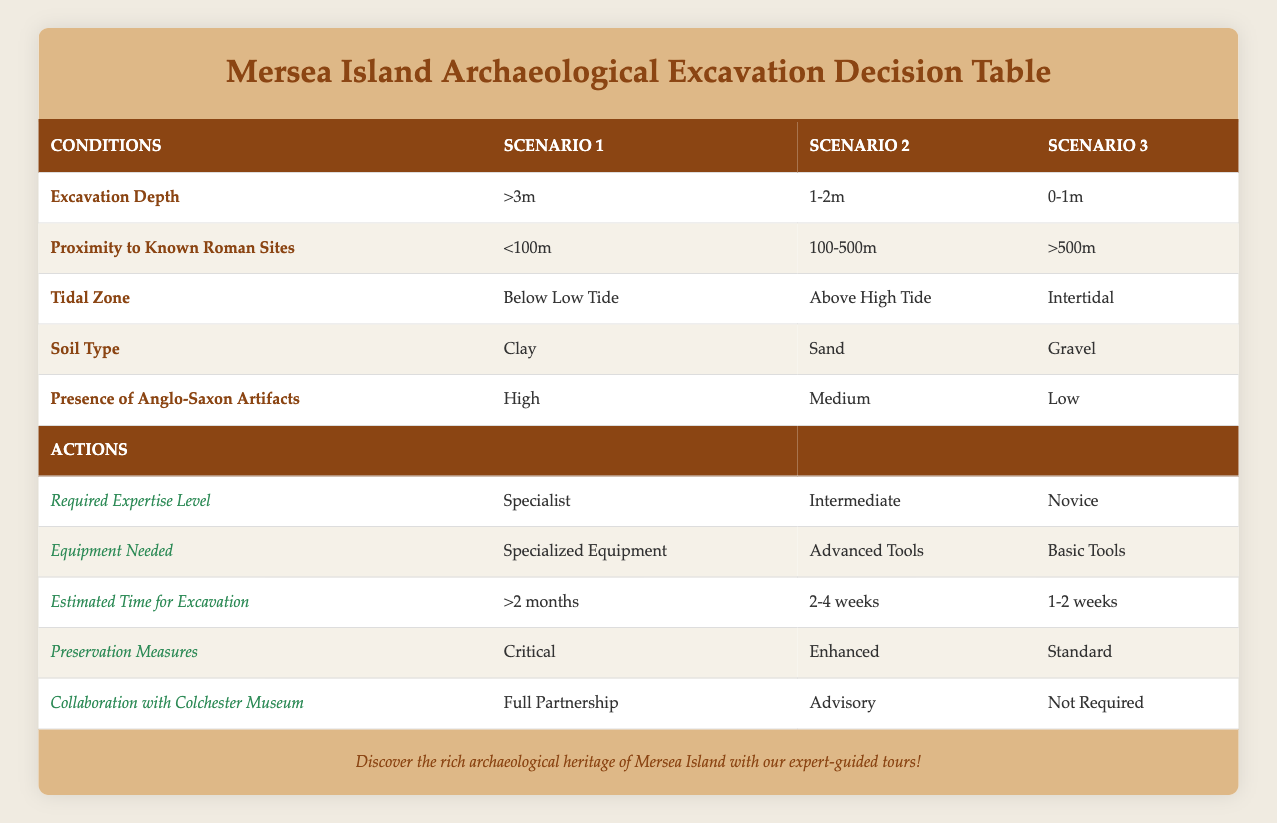What is the required expertise level for an excavation depth of ">3m" and proximity to known Roman sites of "<100m"? The table indicates that for an excavation depth of ">3m" and a proximity of "<100m", the required expertise level is "Specialist".
Answer: Specialist What is the estimated time for excavation when the tidal zone is "Above High Tide"? According to the table, when the tidal zone is "Above High Tide", the estimated time for excavation is "2-4 weeks".
Answer: 2-4 weeks Is collaboration with the Colchester Museum required when the presence of Anglo-Saxon artifacts is low? The table shows that when the presence of Anglo-Saxon artifacts is "Low", collaboration with the Colchester Museum is listed as "Not Required".
Answer: Yes Which soil type requires specialized equipment? The table specifies that the soil type "Clay" corresponds with the need for "Specialized Equipment", which appears in the scenario where excavation depth is ">3m".
Answer: Clay If the excavation depth is "0-1m", what are the preservation measures required? In the table, for the excavation depth of "0-1m", the preservation measures are categorized as "Standard".
Answer: Standard What is the total number of actions for a scenario with "1-2m" excavation depth? We can count the number of action rows available for the scenario with "1-2m" excavation depth. The actions listed are: Required Expertise Level, Equipment Needed, Estimated Time for Excavation, Preservation Measures, and Collaboration with Colchester Museum, totaling 5 actions.
Answer: 5 If a site has "Peat" as the soil type and is more than 500m from known Roman sites, how many weeks should the excavation take? The table suggests that for "0-1m" excavation depth and with more than 500m proximity to known Roman sites, the estimated time for excavation is "1-2 weeks".
Answer: 1-2 weeks Does having "Medium" presence of Anglo-Saxon artifacts and "Sand" soil type require specialist equipment? The table displays that with "Medium" presence of Anglo-Saxon artifacts and "Sand" soil type, the required equipment is "Advanced Tools", not specialist equipment.
Answer: No What is the preservation measure when working in the tidal zone "Below Low Tide" and excavation depth is ">3m"? According to the table, in the scenario with tidal zone "Below Low Tide" and excavation depth ">3m", the preservation measures required are classified as "Critical".
Answer: Critical 